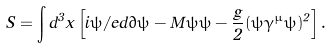<formula> <loc_0><loc_0><loc_500><loc_500>S = \int d ^ { 3 } x \left [ i \bar { \psi } \slash e d \partial \psi - M \bar { \psi } \psi - \frac { g } { 2 } ( \bar { \psi } \gamma ^ { \mu } \psi ) ^ { 2 } \right ] .</formula> 